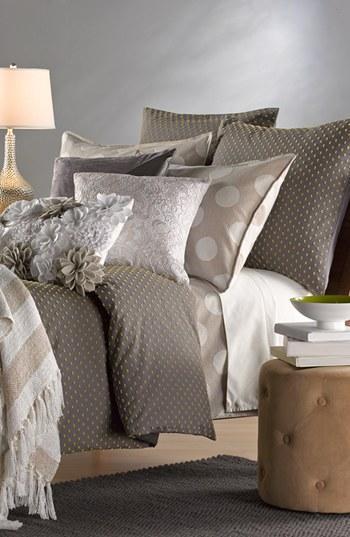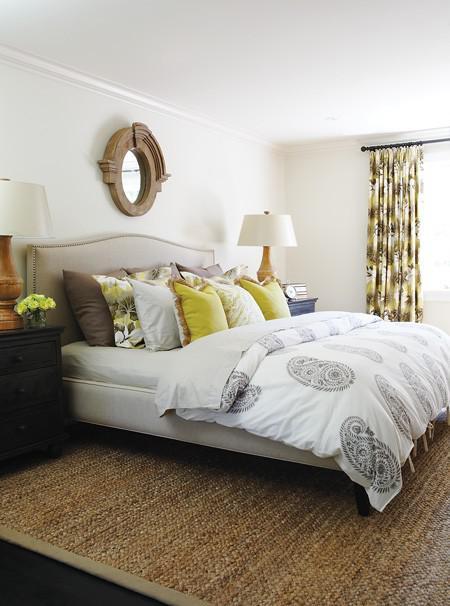The first image is the image on the left, the second image is the image on the right. For the images shown, is this caption "Several throw pillows sit on a bed in at least one of the images." true? Answer yes or no. Yes. The first image is the image on the left, the second image is the image on the right. Evaluate the accuracy of this statement regarding the images: "An image shows a bed that features a round design element.". Is it true? Answer yes or no. No. 